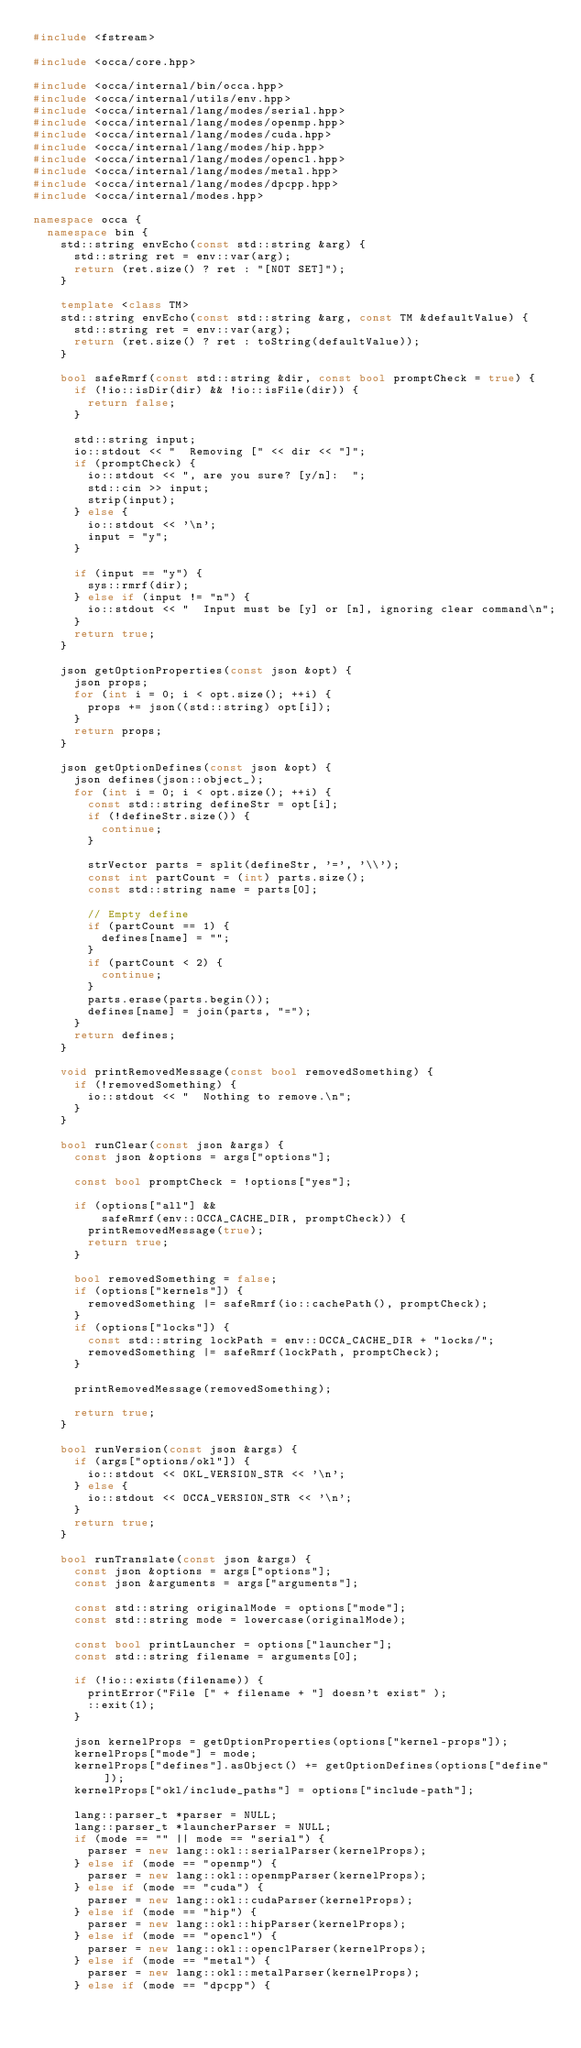<code> <loc_0><loc_0><loc_500><loc_500><_C++_>#include <fstream>

#include <occa/core.hpp>

#include <occa/internal/bin/occa.hpp>
#include <occa/internal/utils/env.hpp>
#include <occa/internal/lang/modes/serial.hpp>
#include <occa/internal/lang/modes/openmp.hpp>
#include <occa/internal/lang/modes/cuda.hpp>
#include <occa/internal/lang/modes/hip.hpp>
#include <occa/internal/lang/modes/opencl.hpp>
#include <occa/internal/lang/modes/metal.hpp>
#include <occa/internal/lang/modes/dpcpp.hpp>
#include <occa/internal/modes.hpp>

namespace occa {
  namespace bin {
    std::string envEcho(const std::string &arg) {
      std::string ret = env::var(arg);
      return (ret.size() ? ret : "[NOT SET]");
    }

    template <class TM>
    std::string envEcho(const std::string &arg, const TM &defaultValue) {
      std::string ret = env::var(arg);
      return (ret.size() ? ret : toString(defaultValue));
    }

    bool safeRmrf(const std::string &dir, const bool promptCheck = true) {
      if (!io::isDir(dir) && !io::isFile(dir)) {
        return false;
      }

      std::string input;
      io::stdout << "  Removing [" << dir << "]";
      if (promptCheck) {
        io::stdout << ", are you sure? [y/n]:  ";
        std::cin >> input;
        strip(input);
      } else {
        io::stdout << '\n';
        input = "y";
      }

      if (input == "y") {
        sys::rmrf(dir);
      } else if (input != "n") {
        io::stdout << "  Input must be [y] or [n], ignoring clear command\n";
      }
      return true;
    }

    json getOptionProperties(const json &opt) {
      json props;
      for (int i = 0; i < opt.size(); ++i) {
        props += json((std::string) opt[i]);
      }
      return props;
    }

    json getOptionDefines(const json &opt) {
      json defines(json::object_);
      for (int i = 0; i < opt.size(); ++i) {
        const std::string defineStr = opt[i];
        if (!defineStr.size()) {
          continue;
        }

        strVector parts = split(defineStr, '=', '\\');
        const int partCount = (int) parts.size();
        const std::string name = parts[0];

        // Empty define
        if (partCount == 1) {
          defines[name] = "";
        }
        if (partCount < 2) {
          continue;
        }
        parts.erase(parts.begin());
        defines[name] = join(parts, "=");
      }
      return defines;
    }

    void printRemovedMessage(const bool removedSomething) {
      if (!removedSomething) {
        io::stdout << "  Nothing to remove.\n";
      }
    }

    bool runClear(const json &args) {
      const json &options = args["options"];

      const bool promptCheck = !options["yes"];

      if (options["all"] &&
          safeRmrf(env::OCCA_CACHE_DIR, promptCheck)) {
        printRemovedMessage(true);
        return true;
      }

      bool removedSomething = false;
      if (options["kernels"]) {
        removedSomething |= safeRmrf(io::cachePath(), promptCheck);
      }
      if (options["locks"]) {
        const std::string lockPath = env::OCCA_CACHE_DIR + "locks/";
        removedSomething |= safeRmrf(lockPath, promptCheck);
      }

      printRemovedMessage(removedSomething);

      return true;
    }

    bool runVersion(const json &args) {
      if (args["options/okl"]) {
        io::stdout << OKL_VERSION_STR << '\n';
      } else {
        io::stdout << OCCA_VERSION_STR << '\n';
      }
      return true;
    }

    bool runTranslate(const json &args) {
      const json &options = args["options"];
      const json &arguments = args["arguments"];

      const std::string originalMode = options["mode"];
      const std::string mode = lowercase(originalMode);

      const bool printLauncher = options["launcher"];
      const std::string filename = arguments[0];

      if (!io::exists(filename)) {
        printError("File [" + filename + "] doesn't exist" );
        ::exit(1);
      }

      json kernelProps = getOptionProperties(options["kernel-props"]);
      kernelProps["mode"] = mode;
      kernelProps["defines"].asObject() += getOptionDefines(options["define"]);
      kernelProps["okl/include_paths"] = options["include-path"];

      lang::parser_t *parser = NULL;
      lang::parser_t *launcherParser = NULL;
      if (mode == "" || mode == "serial") {
        parser = new lang::okl::serialParser(kernelProps);
      } else if (mode == "openmp") {
        parser = new lang::okl::openmpParser(kernelProps);
      } else if (mode == "cuda") {
        parser = new lang::okl::cudaParser(kernelProps);
      } else if (mode == "hip") {
        parser = new lang::okl::hipParser(kernelProps);
      } else if (mode == "opencl") {
        parser = new lang::okl::openclParser(kernelProps);
      } else if (mode == "metal") {
        parser = new lang::okl::metalParser(kernelProps);
      } else if (mode == "dpcpp") {</code> 